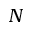Convert formula to latex. <formula><loc_0><loc_0><loc_500><loc_500>N</formula> 